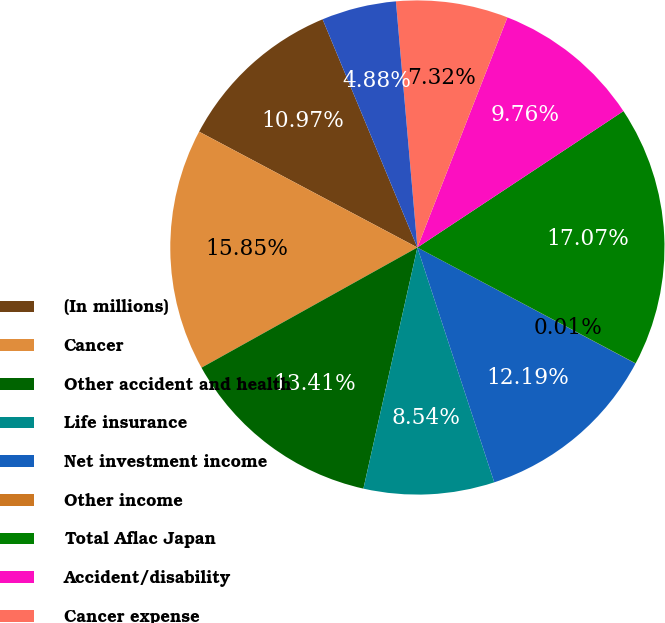<chart> <loc_0><loc_0><loc_500><loc_500><pie_chart><fcel>(In millions)<fcel>Cancer<fcel>Other accident and health<fcel>Life insurance<fcel>Net investment income<fcel>Other income<fcel>Total Aflac Japan<fcel>Accident/disability<fcel>Cancer expense<fcel>Other health<nl><fcel>10.97%<fcel>15.85%<fcel>13.41%<fcel>8.54%<fcel>12.19%<fcel>0.01%<fcel>17.07%<fcel>9.76%<fcel>7.32%<fcel>4.88%<nl></chart> 